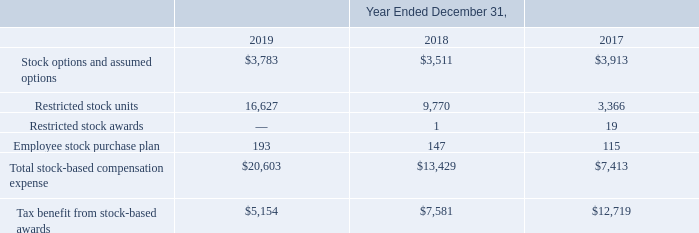Note 15. Stock-Based Compensation
The following table summarizes the components of non-cash stock-based compensation expense (in thousands):
2015 Equity Incentive Plan
We issue stock options pursuant to our 2015 Plan. The 2015 Plan allows for the grant of stock options to employees and for the grant of nonqualified stock options, stock appreciation rights, restricted stock awards, restricted stock unit awards, or RSUs, performance-based stock awards, and other forms of equity compensation to our employees, directors and non-employee directors and consultants.
In June 2015, our board of directors adopted and our stockholders approved our 2015 Plan pursuant to which we initially reserved a total of 4,700,000 shares of common stock for issuance under the 2015 Plan, which included shares of our common stock previously reserved for issuance under our Amended and Restated 2009 Stock Incentive Plan, or the 2009 Plan. The number of shares of common stock reserved for issuance under the 2015 Plan will automatically increase on January 1 each year, for a period of not more than ten years, commencing on January 1, 2016 through January 1, 2024, by 5% of the total number of shares of common stock outstanding on December 31 of the preceding calendar year, or a lesser number of shares as may be determined by the board of directors. As a result of the adoption of the 2015 Plan, no further grants may be made under the 2009 Plan. As of December 31, 2019, 6,527,550 shares remained available for future grant under the 2015 Plan.
Stock Options
Stock options under the 2015 Plan have been granted at exercise prices based on the closing price of our common stock on the date of grant. Stock options under the 2009 Plan were granted at exercise prices as determined by the board of directors to be the fair market value of our common stock. Our stock options generally vest over a five-year period and each option, if not exercised or forfeited, expires on the tenth anniversary of the grant date.
Certain stock options granted under the 2015 Plan and previously granted under the 2009 Plan may be exercised before the options have vested. Unvested shares issued as a result of early exercise are subject to repurchase by us upon termination of employment or services at the original exercise price. The proceeds from the early exercise of stock options are initially recorded as a current liability and are reclassified to common stock and additional paid-in capital as the awards vest and our repurchase right lapses. There were 250 and 957 unvested shares of common stock outstanding subject to our right of repurchase as of December 31, 2019 and 2018, respectively. We repurchased 27 and 107 of these unvested shares of common stock related to early exercised stock options in connection with employee terminations during the years ended December 31, 2019 and 2018, respectively. We recorded less than $0.1 million in accounts payable, accrued expenses and other current liabilities on our consolidated balance sheets for the proceeds from the early exercise of the unvested stock options as of December 31, 2019 and 2018.
We account for stock-based compensation options based on the fair value of the award as of the grant date. We recognize stock-based compensation expense using the accelerated attribution method, net of actual forfeitures, in which compensation cost for each vesting tranche in an award is recognized ratably from the service inception date to the vesting date for that tranche.
We value our stock options using the Black-Scholes option pricing model, which requires the input of subjective assumptions, including the risk-free interest rate, expected term, expected stock price volatility and dividend yield. The risk-free interest rate assumption is based upon observed interest rates for constant maturity U.S. Treasury securities consistent with the expected term of our stock options. The expected term represents the period of time the stock options are expected to be outstanding and is based on the "simplified method." Under the "simplified method," the expected term of an option is presumed to be the mid-point between the vesting date and the end of the contractual term. We use the "simplified method" due to the lack of sufficient historical exercise data to provide a reasonable basis upon which to otherwise estimate the expected term of the stock options. Beginning in November 2019, the expected volatility for options granted is based on historical volatilities of our stock over the estimated expected term of the stock options. The expected volatility for options granted prior to November 2019 was based on historical volatilities of our stock and publicly traded stock of comparable companies over the estimated expected term of the stock options.
There were 186,500, 219,450 and 252,100 stock options granted during the years ended December 31, 2019, 2018 and 2017, respectively. We declared and paid dividends in June 2015 in anticipation of our IPO, which we closed on July 1, 2015. Subsequent to the IPO, we do not expect to declare or pay dividends on a recurring basis. As such, we assume that the dividend rate is 0%.
What was the value of restricted stock units in 2019??
Answer scale should be: thousand. 16,627. What was the Stock options and assumed options in 2018?
Answer scale should be: thousand. 3,511. Which years does the table provide information for  the components of non-cash stock-based compensation expense for? 2019, 2018, 2017. How many years did Stock options and assumed options exceed $3,000 thousand? 2019##2018##2017
Answer: 3. What was the change in the Employee stock purchase plan between 2018 and 2019?
Answer scale should be: thousand. 193-147
Answer: 46. What was the percentage change in the Total stock-based compensation expense between 2018 and 2019?
Answer scale should be: percent. (20,603-13,429)/13,429
Answer: 53.42. 